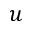<formula> <loc_0><loc_0><loc_500><loc_500>u</formula> 